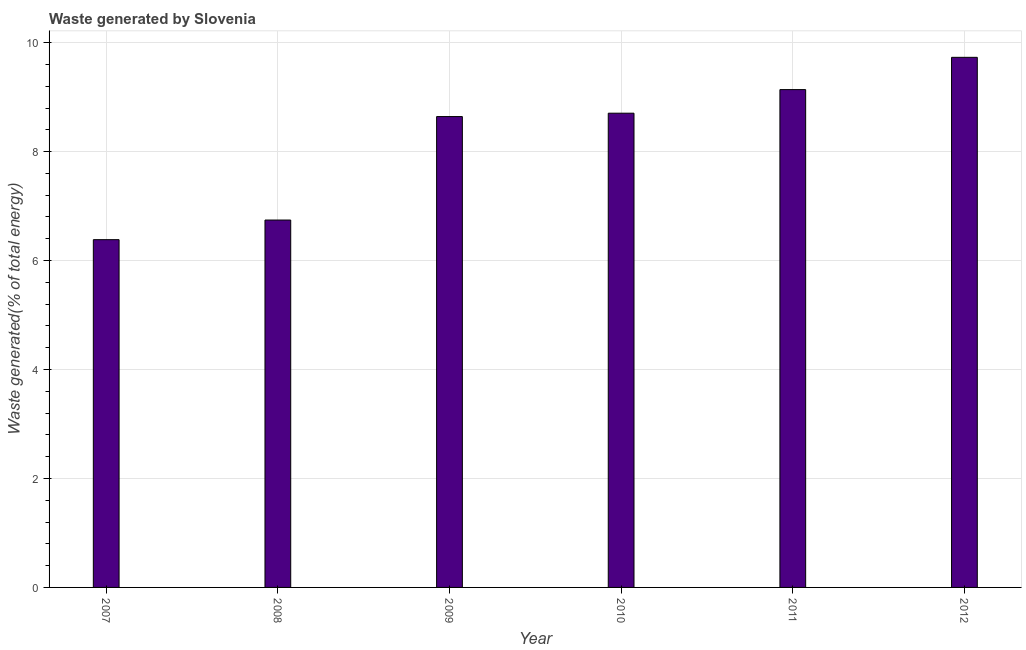Does the graph contain grids?
Your response must be concise. Yes. What is the title of the graph?
Your answer should be very brief. Waste generated by Slovenia. What is the label or title of the X-axis?
Provide a succinct answer. Year. What is the label or title of the Y-axis?
Provide a succinct answer. Waste generated(% of total energy). What is the amount of waste generated in 2009?
Provide a succinct answer. 8.64. Across all years, what is the maximum amount of waste generated?
Provide a succinct answer. 9.73. Across all years, what is the minimum amount of waste generated?
Your answer should be very brief. 6.38. In which year was the amount of waste generated maximum?
Provide a succinct answer. 2012. In which year was the amount of waste generated minimum?
Offer a very short reply. 2007. What is the sum of the amount of waste generated?
Your answer should be very brief. 49.34. What is the difference between the amount of waste generated in 2007 and 2008?
Offer a very short reply. -0.36. What is the average amount of waste generated per year?
Make the answer very short. 8.22. What is the median amount of waste generated?
Your answer should be compact. 8.67. Do a majority of the years between 2008 and 2007 (inclusive) have amount of waste generated greater than 3.6 %?
Give a very brief answer. No. What is the ratio of the amount of waste generated in 2008 to that in 2012?
Your answer should be very brief. 0.69. Is the difference between the amount of waste generated in 2011 and 2012 greater than the difference between any two years?
Offer a very short reply. No. What is the difference between the highest and the second highest amount of waste generated?
Give a very brief answer. 0.59. Is the sum of the amount of waste generated in 2008 and 2009 greater than the maximum amount of waste generated across all years?
Your answer should be very brief. Yes. What is the difference between the highest and the lowest amount of waste generated?
Offer a very short reply. 3.35. In how many years, is the amount of waste generated greater than the average amount of waste generated taken over all years?
Ensure brevity in your answer.  4. Are the values on the major ticks of Y-axis written in scientific E-notation?
Your answer should be very brief. No. What is the Waste generated(% of total energy) in 2007?
Provide a succinct answer. 6.38. What is the Waste generated(% of total energy) in 2008?
Offer a very short reply. 6.74. What is the Waste generated(% of total energy) in 2009?
Offer a very short reply. 8.64. What is the Waste generated(% of total energy) of 2010?
Provide a short and direct response. 8.7. What is the Waste generated(% of total energy) in 2011?
Offer a very short reply. 9.14. What is the Waste generated(% of total energy) of 2012?
Provide a succinct answer. 9.73. What is the difference between the Waste generated(% of total energy) in 2007 and 2008?
Offer a very short reply. -0.36. What is the difference between the Waste generated(% of total energy) in 2007 and 2009?
Give a very brief answer. -2.26. What is the difference between the Waste generated(% of total energy) in 2007 and 2010?
Ensure brevity in your answer.  -2.32. What is the difference between the Waste generated(% of total energy) in 2007 and 2011?
Offer a terse response. -2.75. What is the difference between the Waste generated(% of total energy) in 2007 and 2012?
Offer a very short reply. -3.35. What is the difference between the Waste generated(% of total energy) in 2008 and 2009?
Make the answer very short. -1.9. What is the difference between the Waste generated(% of total energy) in 2008 and 2010?
Your answer should be very brief. -1.96. What is the difference between the Waste generated(% of total energy) in 2008 and 2011?
Your answer should be compact. -2.39. What is the difference between the Waste generated(% of total energy) in 2008 and 2012?
Provide a short and direct response. -2.99. What is the difference between the Waste generated(% of total energy) in 2009 and 2010?
Your response must be concise. -0.06. What is the difference between the Waste generated(% of total energy) in 2009 and 2011?
Provide a succinct answer. -0.49. What is the difference between the Waste generated(% of total energy) in 2009 and 2012?
Offer a very short reply. -1.09. What is the difference between the Waste generated(% of total energy) in 2010 and 2011?
Your response must be concise. -0.43. What is the difference between the Waste generated(% of total energy) in 2010 and 2012?
Your answer should be compact. -1.03. What is the difference between the Waste generated(% of total energy) in 2011 and 2012?
Keep it short and to the point. -0.59. What is the ratio of the Waste generated(% of total energy) in 2007 to that in 2008?
Give a very brief answer. 0.95. What is the ratio of the Waste generated(% of total energy) in 2007 to that in 2009?
Ensure brevity in your answer.  0.74. What is the ratio of the Waste generated(% of total energy) in 2007 to that in 2010?
Your answer should be very brief. 0.73. What is the ratio of the Waste generated(% of total energy) in 2007 to that in 2011?
Your response must be concise. 0.7. What is the ratio of the Waste generated(% of total energy) in 2007 to that in 2012?
Provide a short and direct response. 0.66. What is the ratio of the Waste generated(% of total energy) in 2008 to that in 2009?
Provide a short and direct response. 0.78. What is the ratio of the Waste generated(% of total energy) in 2008 to that in 2010?
Your response must be concise. 0.78. What is the ratio of the Waste generated(% of total energy) in 2008 to that in 2011?
Make the answer very short. 0.74. What is the ratio of the Waste generated(% of total energy) in 2008 to that in 2012?
Keep it short and to the point. 0.69. What is the ratio of the Waste generated(% of total energy) in 2009 to that in 2011?
Your response must be concise. 0.95. What is the ratio of the Waste generated(% of total energy) in 2009 to that in 2012?
Provide a short and direct response. 0.89. What is the ratio of the Waste generated(% of total energy) in 2010 to that in 2011?
Keep it short and to the point. 0.95. What is the ratio of the Waste generated(% of total energy) in 2010 to that in 2012?
Ensure brevity in your answer.  0.9. What is the ratio of the Waste generated(% of total energy) in 2011 to that in 2012?
Ensure brevity in your answer.  0.94. 